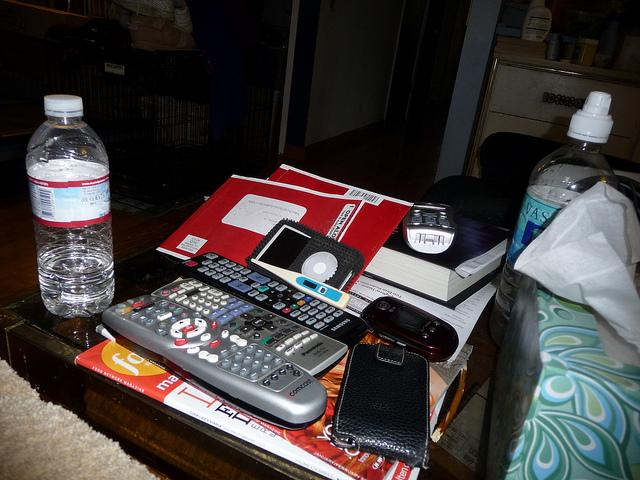The red envelopes on the table indicate that there is what electronic device in the room?

Choices:
A) dvd player
B) vhs player
C) cd player
D) cable box dvd player 